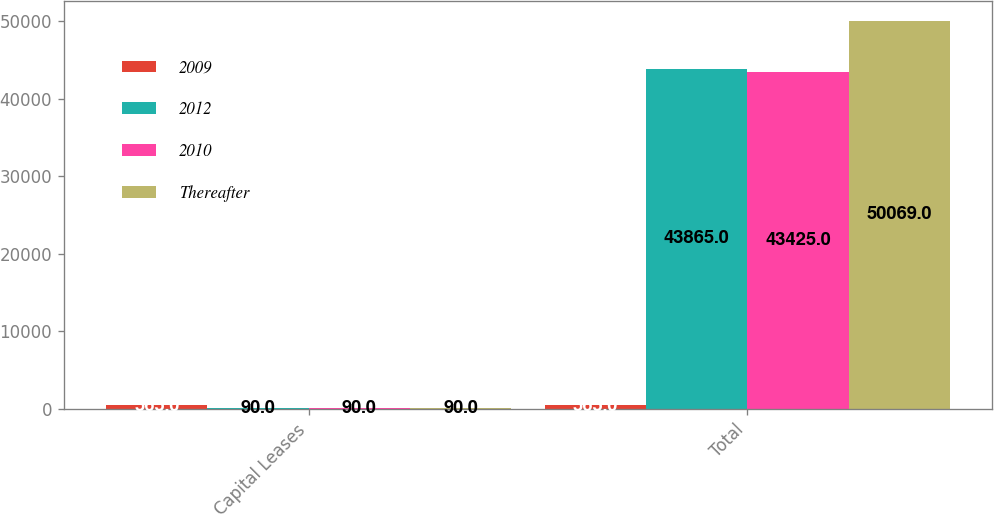Convert chart. <chart><loc_0><loc_0><loc_500><loc_500><stacked_bar_chart><ecel><fcel>Capital Leases<fcel>Total<nl><fcel>2009<fcel>565<fcel>565<nl><fcel>2012<fcel>90<fcel>43865<nl><fcel>2010<fcel>90<fcel>43425<nl><fcel>Thereafter<fcel>90<fcel>50069<nl></chart> 